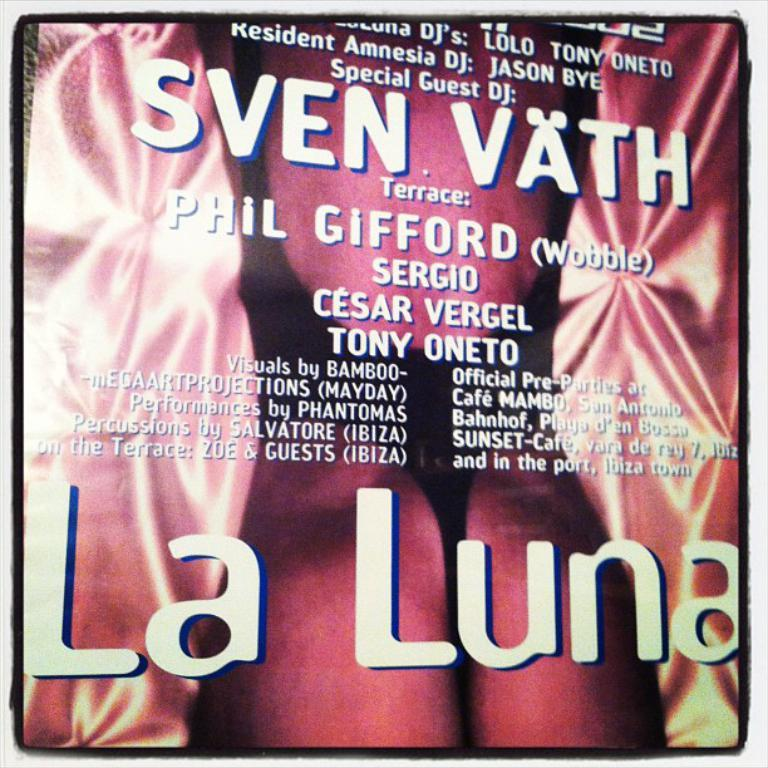<image>
Give a short and clear explanation of the subsequent image. Special Guest DJ: Sven Vath and Terrace Phil Gifford, performing La Luna. 